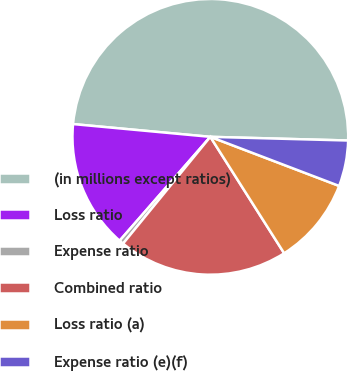Convert chart to OTSL. <chart><loc_0><loc_0><loc_500><loc_500><pie_chart><fcel>(in millions except ratios)<fcel>Loss ratio<fcel>Expense ratio<fcel>Combined ratio<fcel>Loss ratio (a)<fcel>Expense ratio (e)(f)<nl><fcel>48.95%<fcel>15.05%<fcel>0.52%<fcel>19.9%<fcel>10.21%<fcel>5.37%<nl></chart> 